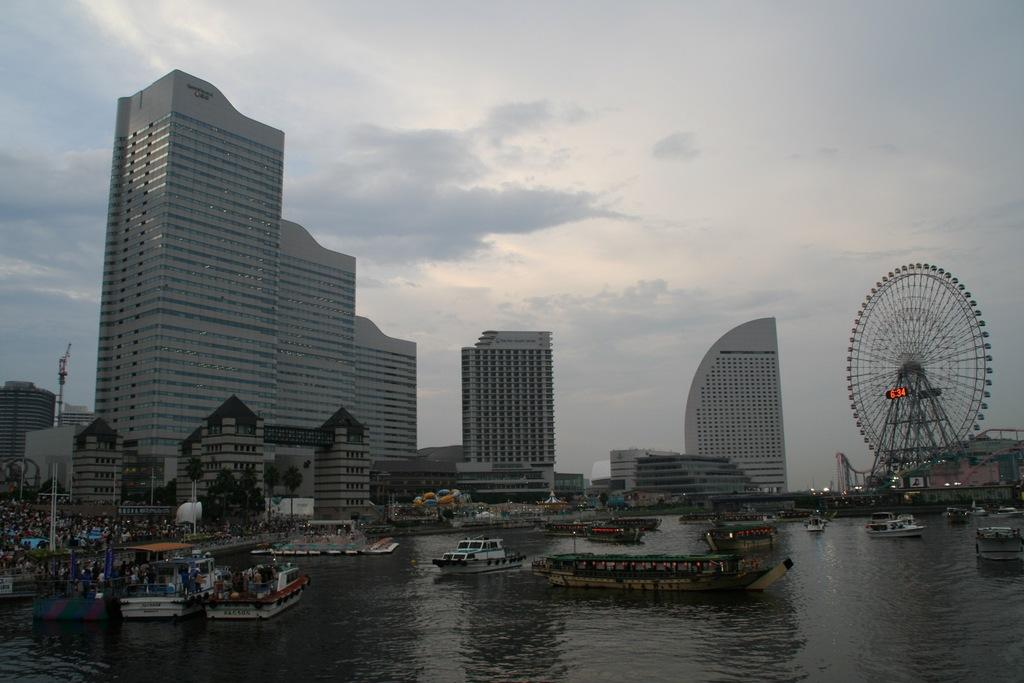What can be seen in the river in the image? There are many ships and boats in the river. What is visible in the background of the image? There are buildings, stalls, trees, and the sky in the background of the image. What type of rifle is being used by the manager in the image? There is no manager or rifle present in the image. What type of turkey can be seen in the image? There is no turkey present in the image. 